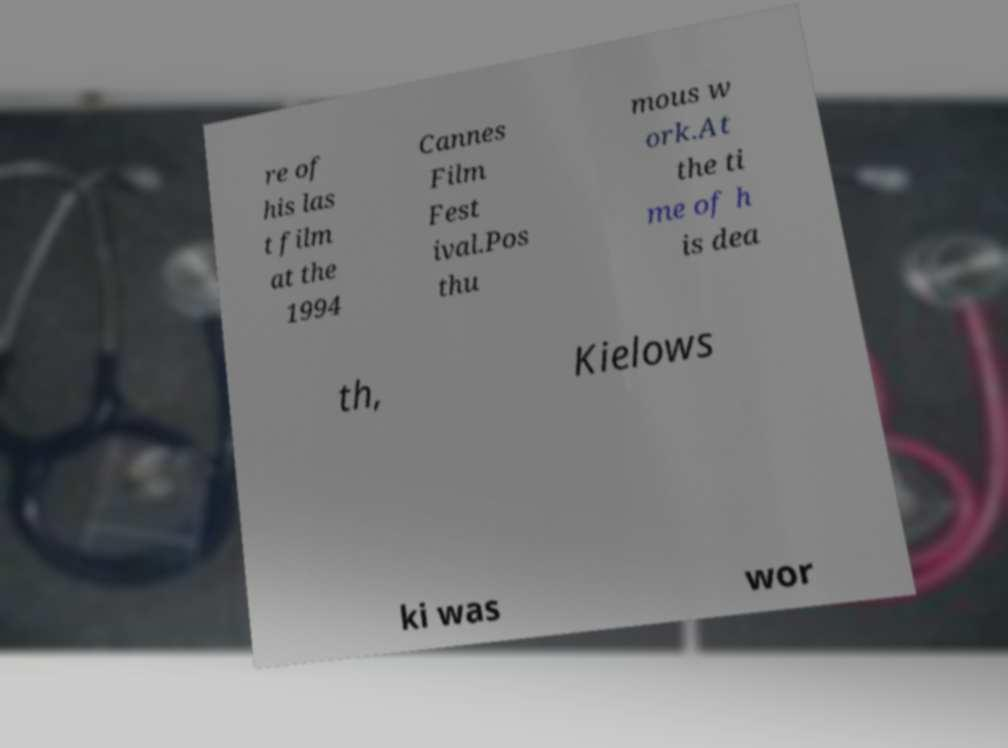There's text embedded in this image that I need extracted. Can you transcribe it verbatim? re of his las t film at the 1994 Cannes Film Fest ival.Pos thu mous w ork.At the ti me of h is dea th, Kielows ki was wor 